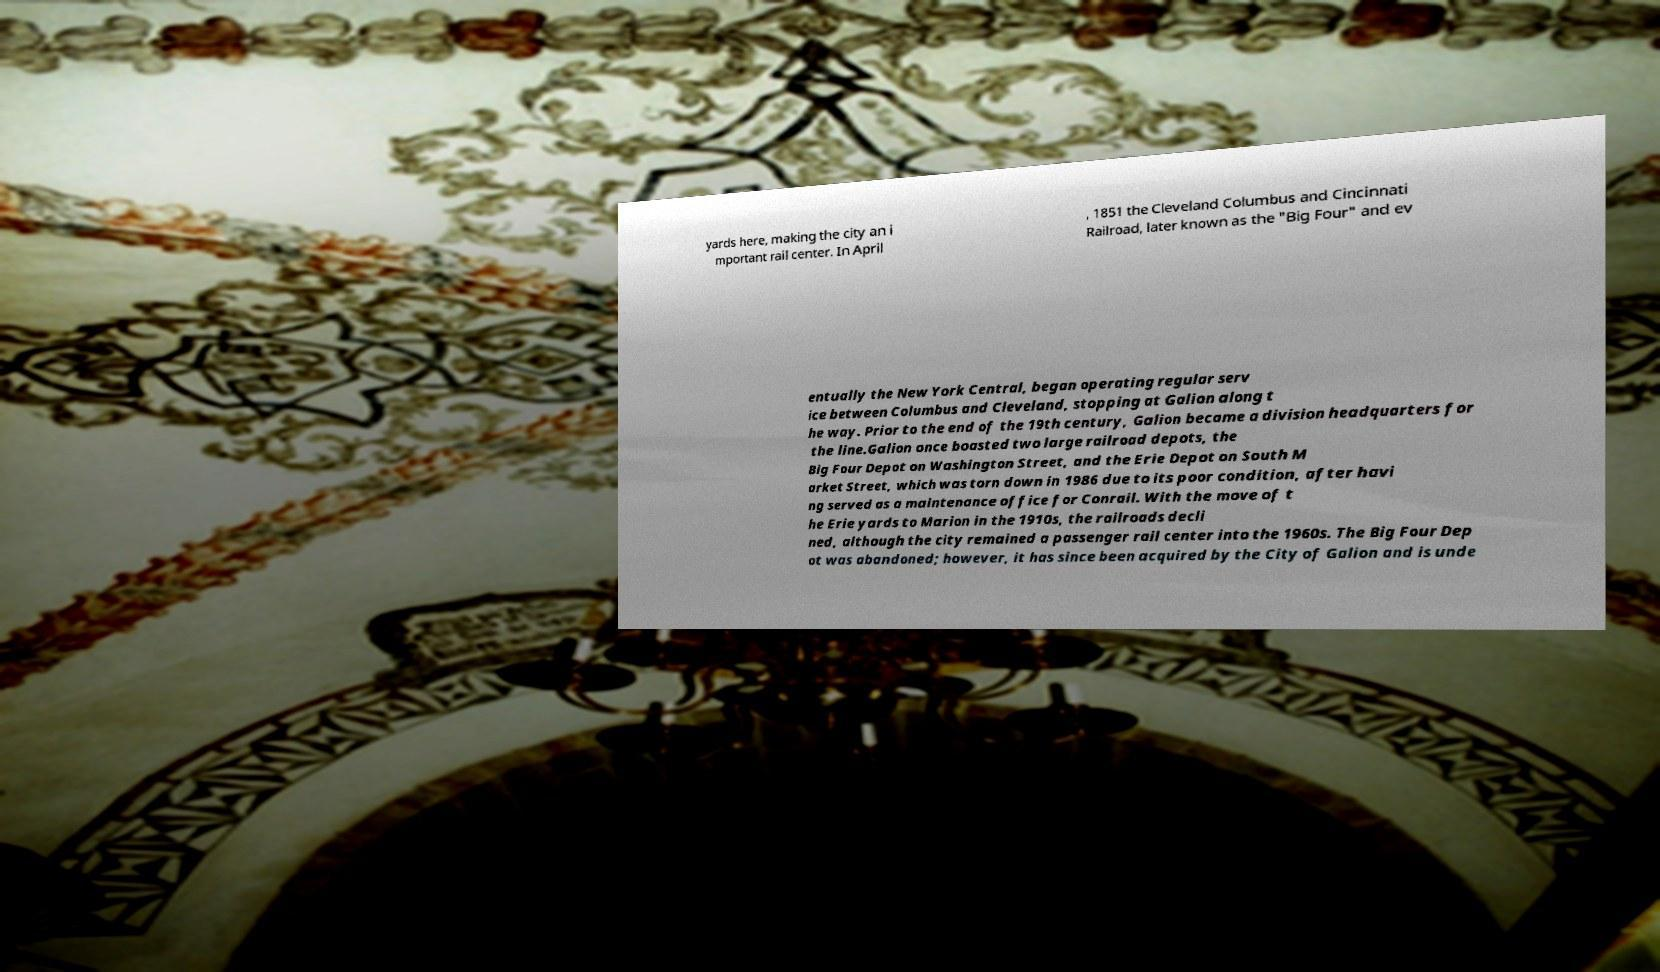For documentation purposes, I need the text within this image transcribed. Could you provide that? yards here, making the city an i mportant rail center. In April , 1851 the Cleveland Columbus and Cincinnati Railroad, later known as the "Big Four" and ev entually the New York Central, began operating regular serv ice between Columbus and Cleveland, stopping at Galion along t he way. Prior to the end of the 19th century, Galion became a division headquarters for the line.Galion once boasted two large railroad depots, the Big Four Depot on Washington Street, and the Erie Depot on South M arket Street, which was torn down in 1986 due to its poor condition, after havi ng served as a maintenance office for Conrail. With the move of t he Erie yards to Marion in the 1910s, the railroads decli ned, although the city remained a passenger rail center into the 1960s. The Big Four Dep ot was abandoned; however, it has since been acquired by the City of Galion and is unde 